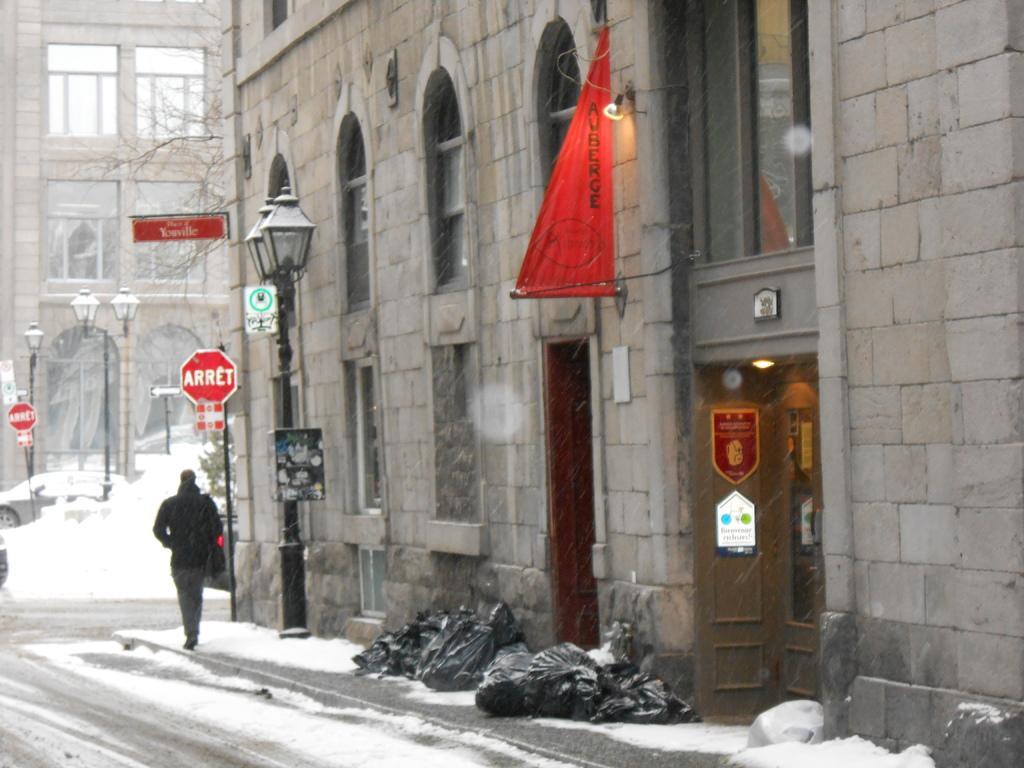Could you give a brief overview of what you see in this image? In this image we can see buildings, poles, lights, trees, care and snow. At the bottom of the image, we can see some objects and a person on the pavement. We can see a road in the left bottom of the image. 